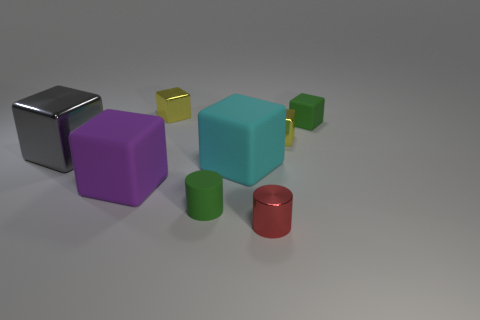Does the matte cylinder have the same color as the tiny matte cube?
Give a very brief answer. Yes. How many tiny yellow objects are on the right side of the yellow block that is behind the green matte object that is right of the small red cylinder?
Provide a succinct answer. 1. What size is the purple matte thing?
Your answer should be compact. Large. There is a red cylinder that is the same size as the green cube; what is its material?
Your answer should be compact. Metal. There is a gray thing; what number of large gray blocks are left of it?
Make the answer very short. 0. Is the small thing behind the green matte block made of the same material as the small green thing that is behind the purple block?
Make the answer very short. No. What shape is the object that is behind the small green object that is right of the tiny green thing that is in front of the gray metallic cube?
Provide a succinct answer. Cube. There is a large purple rubber thing; what shape is it?
Provide a succinct answer. Cube. What is the shape of the purple object that is the same size as the cyan object?
Provide a short and direct response. Cube. What number of other things are the same color as the rubber cylinder?
Provide a short and direct response. 1. 